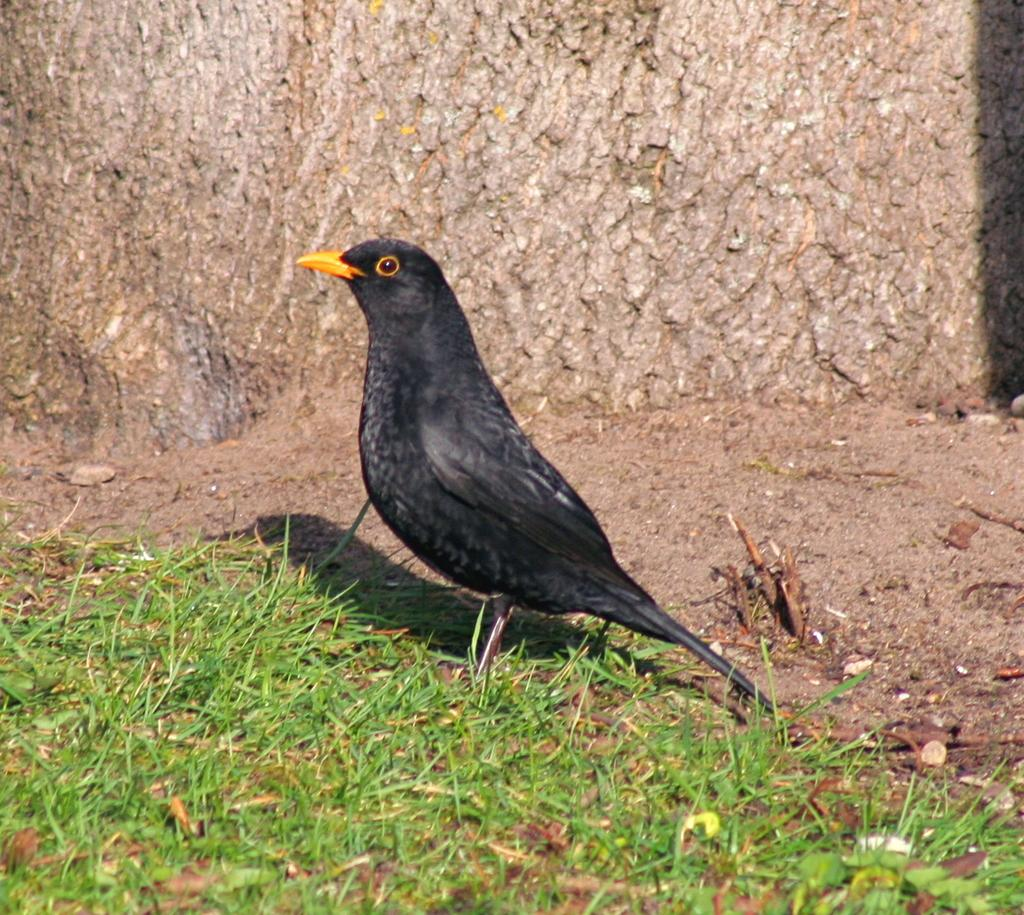What can be seen in the background of the image? There is a tree trunk in the background of the image. What type of bird is present in the image? There is a black bird on the ground in the image. What is the color and texture of the grass in the image? Green grass is visible at the bottom portion of the image. What type of paper is the bird using to build its nest in the image? There is no nest or paper present in the image; it features a black bird on the ground and a tree trunk in the background. What does the tree trunk need to grow in the image? The tree trunk does not need anything in the image, as it is already a mature tree. 